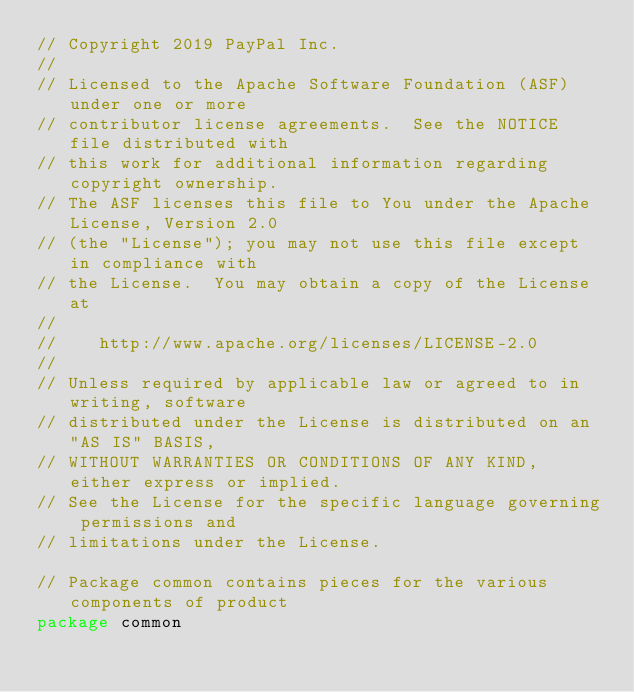Convert code to text. <code><loc_0><loc_0><loc_500><loc_500><_Go_>// Copyright 2019 PayPal Inc.
//
// Licensed to the Apache Software Foundation (ASF) under one or more
// contributor license agreements.  See the NOTICE file distributed with
// this work for additional information regarding copyright ownership.
// The ASF licenses this file to You under the Apache License, Version 2.0
// (the "License"); you may not use this file except in compliance with
// the License.  You may obtain a copy of the License at
//
//    http://www.apache.org/licenses/LICENSE-2.0
//
// Unless required by applicable law or agreed to in writing, software
// distributed under the License is distributed on an "AS IS" BASIS,
// WITHOUT WARRANTIES OR CONDITIONS OF ANY KIND, either express or implied.
// See the License for the specific language governing permissions and
// limitations under the License.

// Package common contains pieces for the various components of product
package common
</code> 